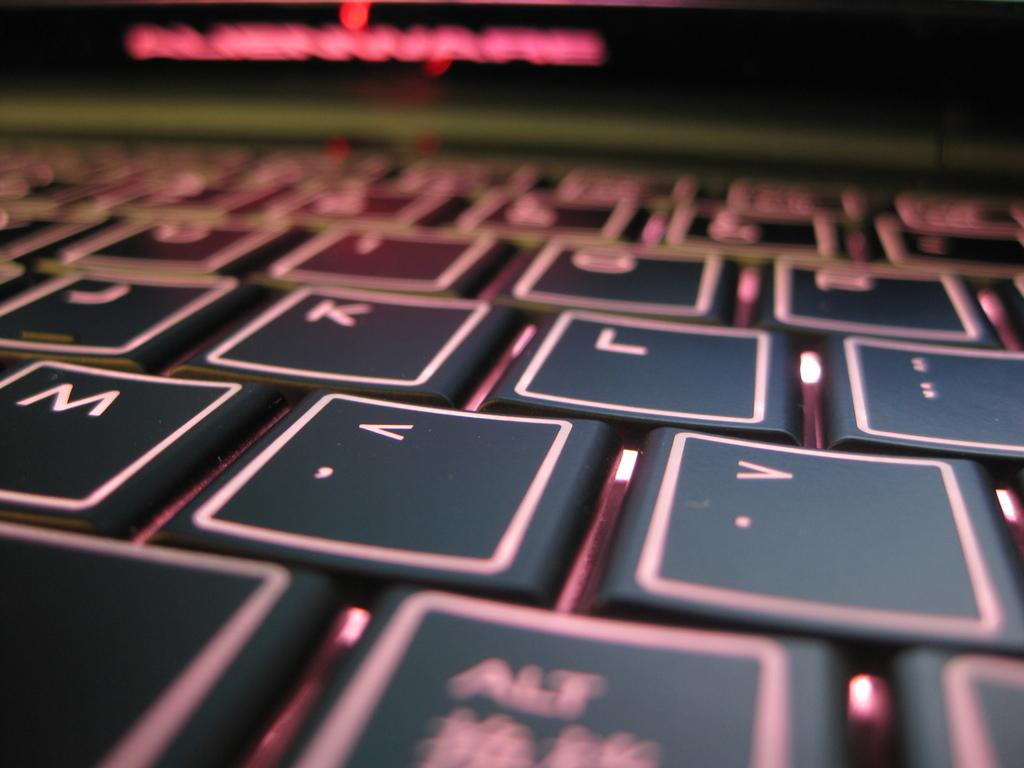Provide a one-sentence caption for the provided image. Partial shot of a flat keyboard with J, k, L and M displayed. 